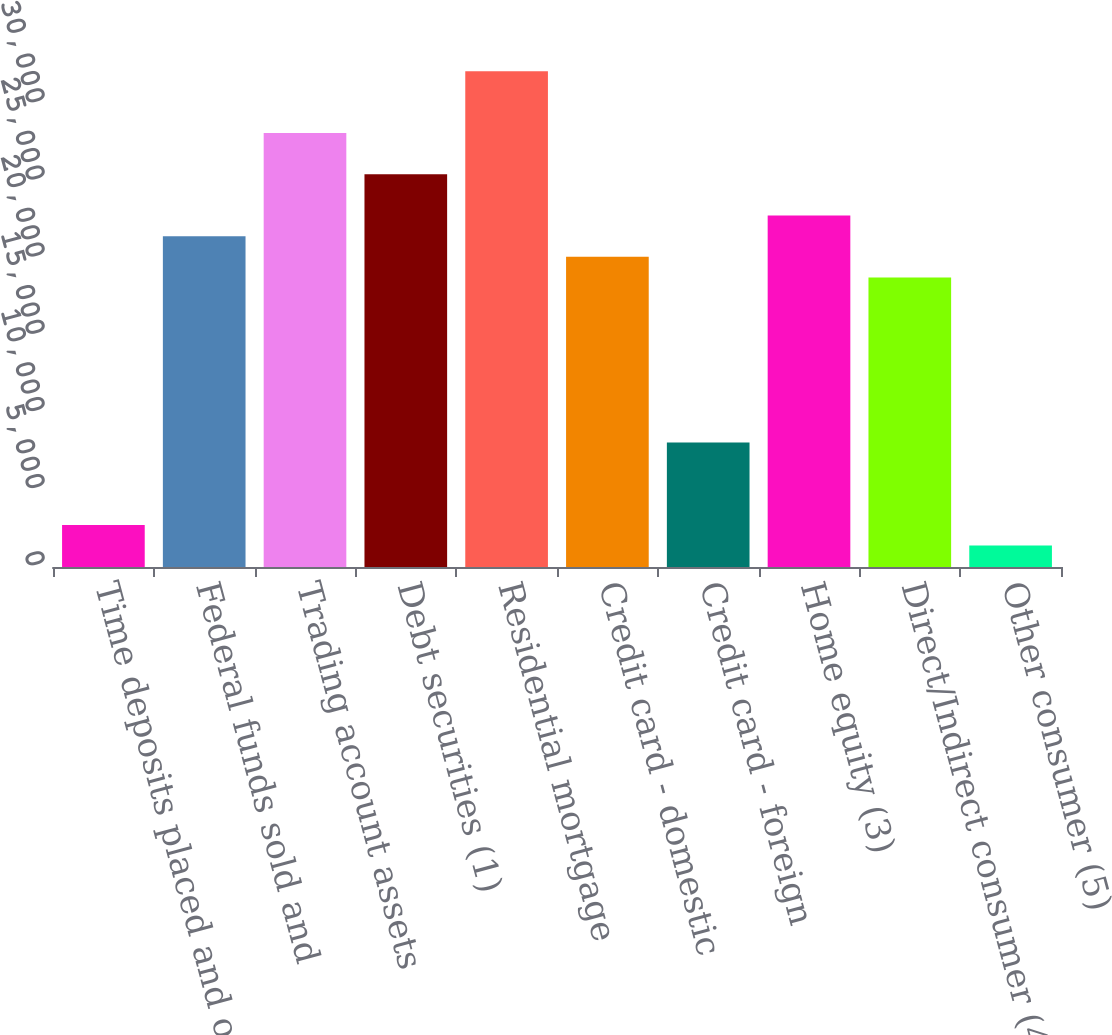Convert chart. <chart><loc_0><loc_0><loc_500><loc_500><bar_chart><fcel>Time deposits placed and other<fcel>Federal funds sold and<fcel>Trading account assets<fcel>Debt securities (1)<fcel>Residential mortgage<fcel>Credit card - domestic<fcel>Credit card - foreign<fcel>Home equity (3)<fcel>Direct/Indirect consumer (4)<fcel>Other consumer (5)<nl><fcel>2723.6<fcel>21438.8<fcel>28122.8<fcel>25449.2<fcel>32133.2<fcel>20102<fcel>8070.8<fcel>22775.6<fcel>18765.2<fcel>1386.8<nl></chart> 